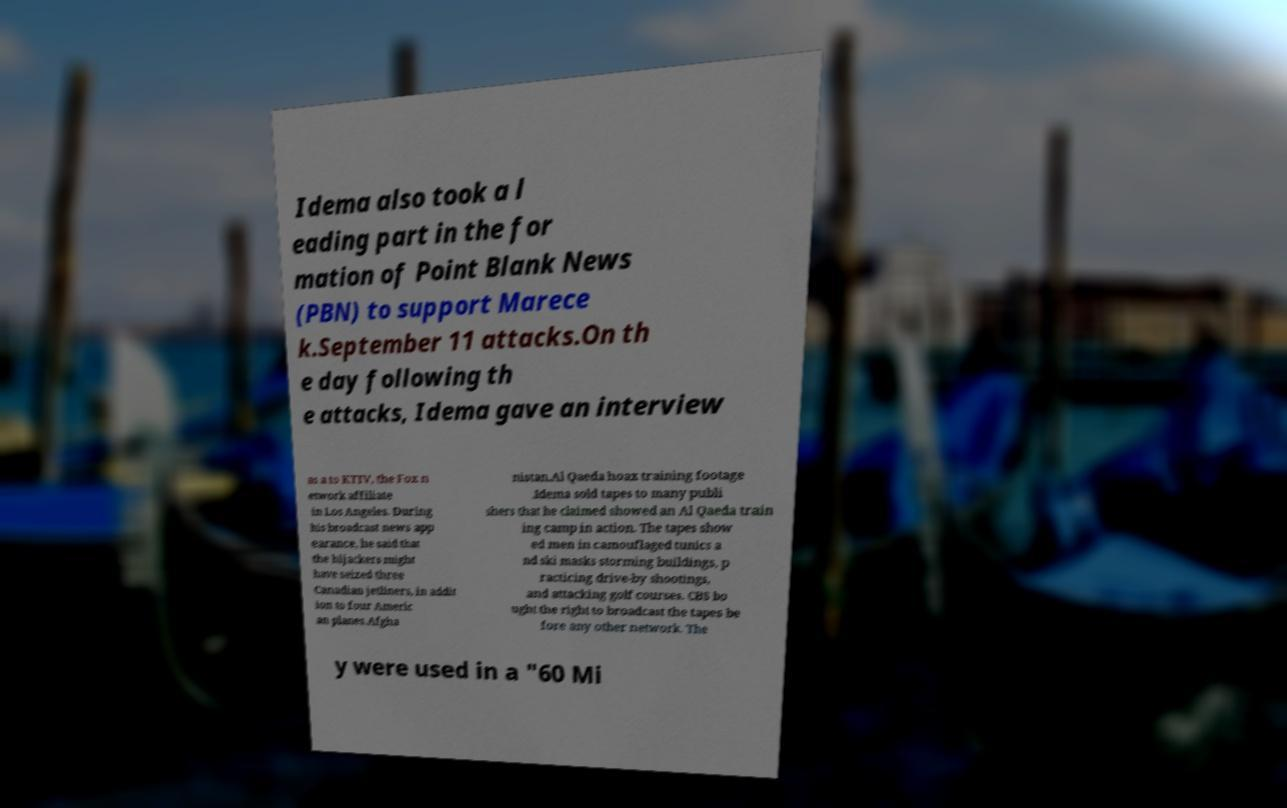Could you assist in decoding the text presented in this image and type it out clearly? Idema also took a l eading part in the for mation of Point Blank News (PBN) to support Marece k.September 11 attacks.On th e day following th e attacks, Idema gave an interview as a to KTTV, the Fox n etwork affiliate in Los Angeles. During his broadcast news app earance, he said that the hijackers might have seized three Canadian jetliners, in addit ion to four Americ an planes.Afgha nistan.Al Qaeda hoax training footage .Idema sold tapes to many publi shers that he claimed showed an Al Qaeda train ing camp in action. The tapes show ed men in camouflaged tunics a nd ski masks storming buildings, p racticing drive-by shootings, and attacking golf courses. CBS bo ught the right to broadcast the tapes be fore any other network. The y were used in a "60 Mi 